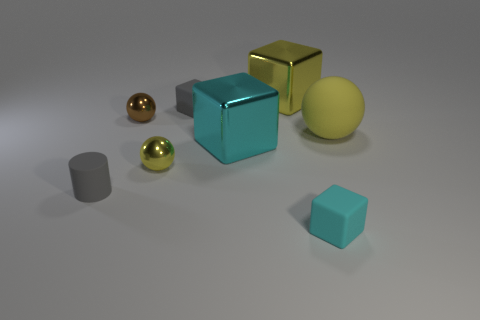Add 2 small yellow metal things. How many objects exist? 10 Subtract 4 cubes. How many cubes are left? 0 Subtract all tiny gray matte cubes. How many cubes are left? 3 Subtract 2 yellow spheres. How many objects are left? 6 Subtract all balls. How many objects are left? 5 Subtract all red cylinders. Subtract all gray cubes. How many cylinders are left? 1 Subtract all purple spheres. How many cyan cubes are left? 2 Subtract all purple shiny cylinders. Subtract all big balls. How many objects are left? 7 Add 5 tiny gray matte cubes. How many tiny gray matte cubes are left? 6 Add 1 gray rubber things. How many gray rubber things exist? 3 